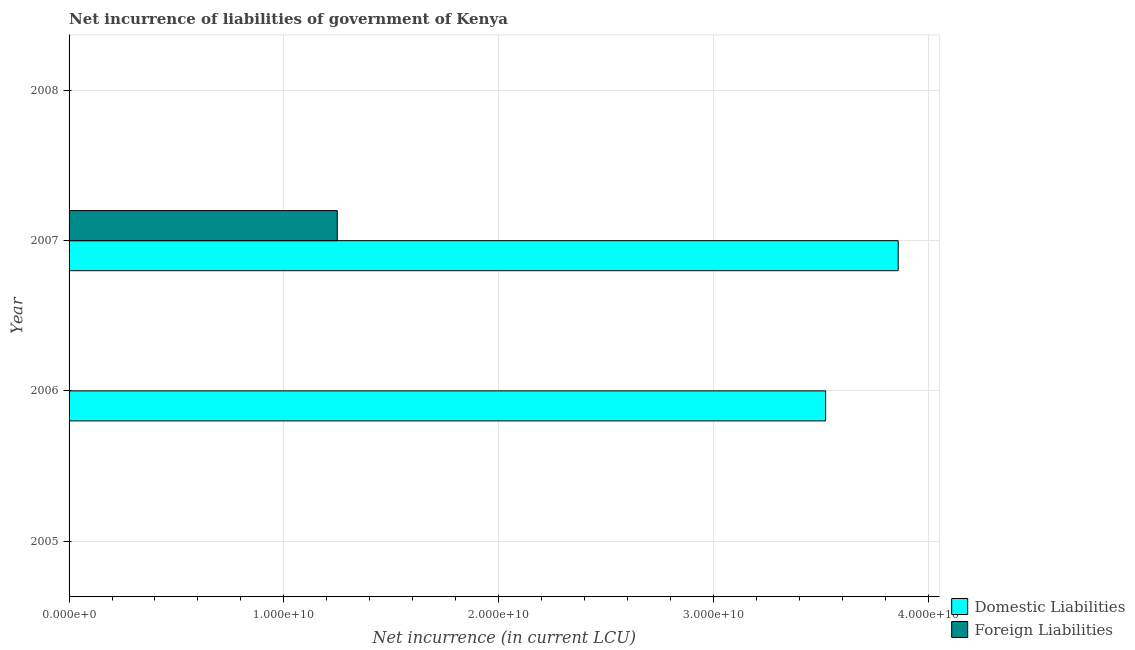How many bars are there on the 4th tick from the top?
Offer a very short reply. 0. How many bars are there on the 3rd tick from the bottom?
Provide a short and direct response. 2. What is the label of the 2nd group of bars from the top?
Ensure brevity in your answer.  2007. In how many cases, is the number of bars for a given year not equal to the number of legend labels?
Offer a terse response. 3. What is the net incurrence of domestic liabilities in 2006?
Your answer should be very brief. 3.52e+1. Across all years, what is the maximum net incurrence of foreign liabilities?
Ensure brevity in your answer.  1.25e+1. Across all years, what is the minimum net incurrence of foreign liabilities?
Your answer should be compact. 0. In which year was the net incurrence of foreign liabilities maximum?
Make the answer very short. 2007. What is the total net incurrence of foreign liabilities in the graph?
Make the answer very short. 1.25e+1. What is the difference between the net incurrence of domestic liabilities in 2006 and that in 2007?
Your response must be concise. -3.38e+09. What is the difference between the net incurrence of foreign liabilities in 2006 and the net incurrence of domestic liabilities in 2007?
Provide a short and direct response. -3.86e+1. What is the average net incurrence of foreign liabilities per year?
Offer a terse response. 3.12e+09. In the year 2007, what is the difference between the net incurrence of domestic liabilities and net incurrence of foreign liabilities?
Provide a short and direct response. 2.61e+1. What is the difference between the highest and the lowest net incurrence of domestic liabilities?
Your response must be concise. 3.86e+1. In how many years, is the net incurrence of domestic liabilities greater than the average net incurrence of domestic liabilities taken over all years?
Provide a succinct answer. 2. How many bars are there?
Your response must be concise. 3. Are all the bars in the graph horizontal?
Your answer should be compact. Yes. How many years are there in the graph?
Keep it short and to the point. 4. Are the values on the major ticks of X-axis written in scientific E-notation?
Your answer should be very brief. Yes. Does the graph contain grids?
Your response must be concise. Yes. How are the legend labels stacked?
Offer a terse response. Vertical. What is the title of the graph?
Your answer should be very brief. Net incurrence of liabilities of government of Kenya. Does "Birth rate" appear as one of the legend labels in the graph?
Make the answer very short. No. What is the label or title of the X-axis?
Your answer should be very brief. Net incurrence (in current LCU). What is the label or title of the Y-axis?
Make the answer very short. Year. What is the Net incurrence (in current LCU) of Domestic Liabilities in 2005?
Offer a very short reply. 0. What is the Net incurrence (in current LCU) of Foreign Liabilities in 2005?
Offer a terse response. 0. What is the Net incurrence (in current LCU) of Domestic Liabilities in 2006?
Provide a short and direct response. 3.52e+1. What is the Net incurrence (in current LCU) of Foreign Liabilities in 2006?
Make the answer very short. 0. What is the Net incurrence (in current LCU) of Domestic Liabilities in 2007?
Provide a succinct answer. 3.86e+1. What is the Net incurrence (in current LCU) of Foreign Liabilities in 2007?
Ensure brevity in your answer.  1.25e+1. What is the Net incurrence (in current LCU) in Domestic Liabilities in 2008?
Your response must be concise. 0. Across all years, what is the maximum Net incurrence (in current LCU) of Domestic Liabilities?
Offer a very short reply. 3.86e+1. Across all years, what is the maximum Net incurrence (in current LCU) in Foreign Liabilities?
Keep it short and to the point. 1.25e+1. Across all years, what is the minimum Net incurrence (in current LCU) in Domestic Liabilities?
Your response must be concise. 0. What is the total Net incurrence (in current LCU) in Domestic Liabilities in the graph?
Provide a succinct answer. 7.38e+1. What is the total Net incurrence (in current LCU) of Foreign Liabilities in the graph?
Ensure brevity in your answer.  1.25e+1. What is the difference between the Net incurrence (in current LCU) in Domestic Liabilities in 2006 and that in 2007?
Provide a succinct answer. -3.38e+09. What is the difference between the Net incurrence (in current LCU) in Domestic Liabilities in 2006 and the Net incurrence (in current LCU) in Foreign Liabilities in 2007?
Ensure brevity in your answer.  2.27e+1. What is the average Net incurrence (in current LCU) of Domestic Liabilities per year?
Offer a terse response. 1.85e+1. What is the average Net incurrence (in current LCU) in Foreign Liabilities per year?
Provide a short and direct response. 3.12e+09. In the year 2007, what is the difference between the Net incurrence (in current LCU) in Domestic Liabilities and Net incurrence (in current LCU) in Foreign Liabilities?
Your response must be concise. 2.61e+1. What is the ratio of the Net incurrence (in current LCU) in Domestic Liabilities in 2006 to that in 2007?
Your answer should be very brief. 0.91. What is the difference between the highest and the lowest Net incurrence (in current LCU) in Domestic Liabilities?
Provide a short and direct response. 3.86e+1. What is the difference between the highest and the lowest Net incurrence (in current LCU) of Foreign Liabilities?
Your response must be concise. 1.25e+1. 